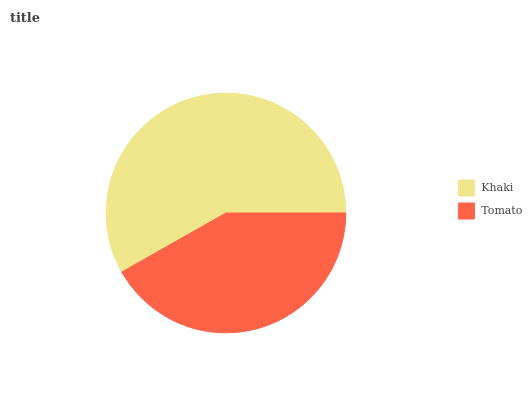Is Tomato the minimum?
Answer yes or no. Yes. Is Khaki the maximum?
Answer yes or no. Yes. Is Tomato the maximum?
Answer yes or no. No. Is Khaki greater than Tomato?
Answer yes or no. Yes. Is Tomato less than Khaki?
Answer yes or no. Yes. Is Tomato greater than Khaki?
Answer yes or no. No. Is Khaki less than Tomato?
Answer yes or no. No. Is Khaki the high median?
Answer yes or no. Yes. Is Tomato the low median?
Answer yes or no. Yes. Is Tomato the high median?
Answer yes or no. No. Is Khaki the low median?
Answer yes or no. No. 